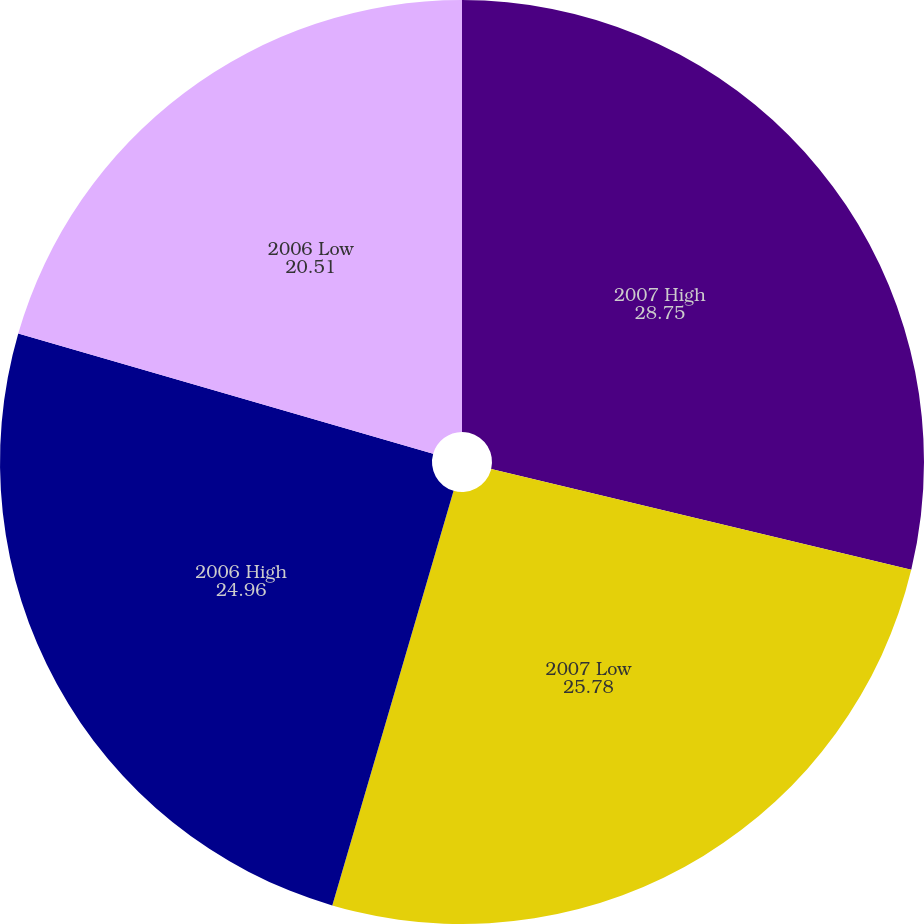Convert chart. <chart><loc_0><loc_0><loc_500><loc_500><pie_chart><fcel>2007 High<fcel>2007 Low<fcel>2006 High<fcel>2006 Low<nl><fcel>28.75%<fcel>25.78%<fcel>24.96%<fcel>20.51%<nl></chart> 